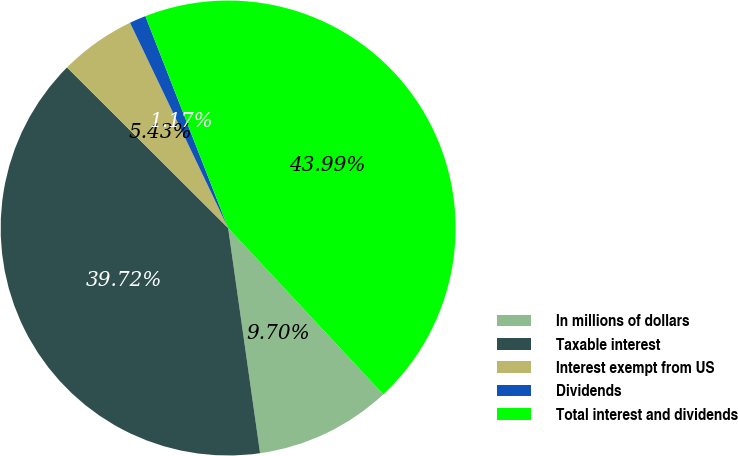Convert chart to OTSL. <chart><loc_0><loc_0><loc_500><loc_500><pie_chart><fcel>In millions of dollars<fcel>Taxable interest<fcel>Interest exempt from US<fcel>Dividends<fcel>Total interest and dividends<nl><fcel>9.7%<fcel>39.72%<fcel>5.43%<fcel>1.17%<fcel>43.99%<nl></chart> 